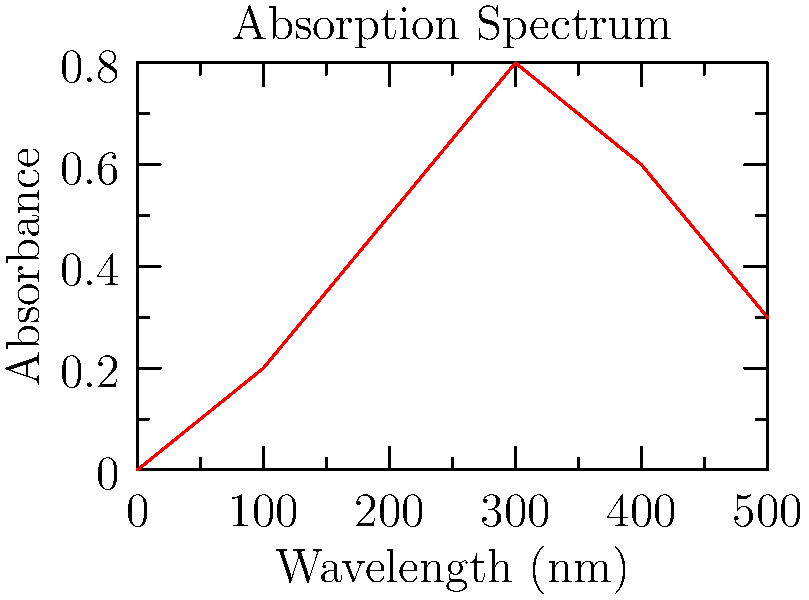In atomic absorption spectroscopy, you observe the absorption spectrum shown above for a heavy metal in a seafood sample. If the characteristic absorption wavelength for cadmium is 228.8 nm, what is the approximate absorbance at this wavelength, and what does this indicate about the concentration of cadmium in the sample? To answer this question, we need to follow these steps:

1. Locate 228.8 nm on the x-axis (Wavelength).
2. Find the corresponding y-value (Absorbance) for this wavelength.
3. Interpret the absorbance value in terms of concentration.

Step 1: 228.8 nm falls between 200 nm and 300 nm on the x-axis.

Step 2: By estimating the y-value at 228.8 nm, we can see that the absorbance is approximately 0.65.

Step 3: In atomic absorption spectroscopy, absorbance is directly proportional to concentration according to the Beer-Lambert law:

$$ A = \epsilon bc $$

Where:
$A$ = absorbance
$\epsilon$ = molar attenuation coefficient
$b$ = path length
$c$ = concentration

An absorbance of 0.65 is significant, indicating a substantial presence of cadmium in the sample. However, to determine the exact concentration, we would need to compare this to a calibration curve created with known concentrations of cadmium.

The high absorbance suggests a relatively high concentration of cadmium in the seafood sample, which could be a concern for food safety, given that cadmium is a toxic heavy metal.
Answer: Absorbance ≈ 0.65, indicating a significant presence of cadmium in the sample. 